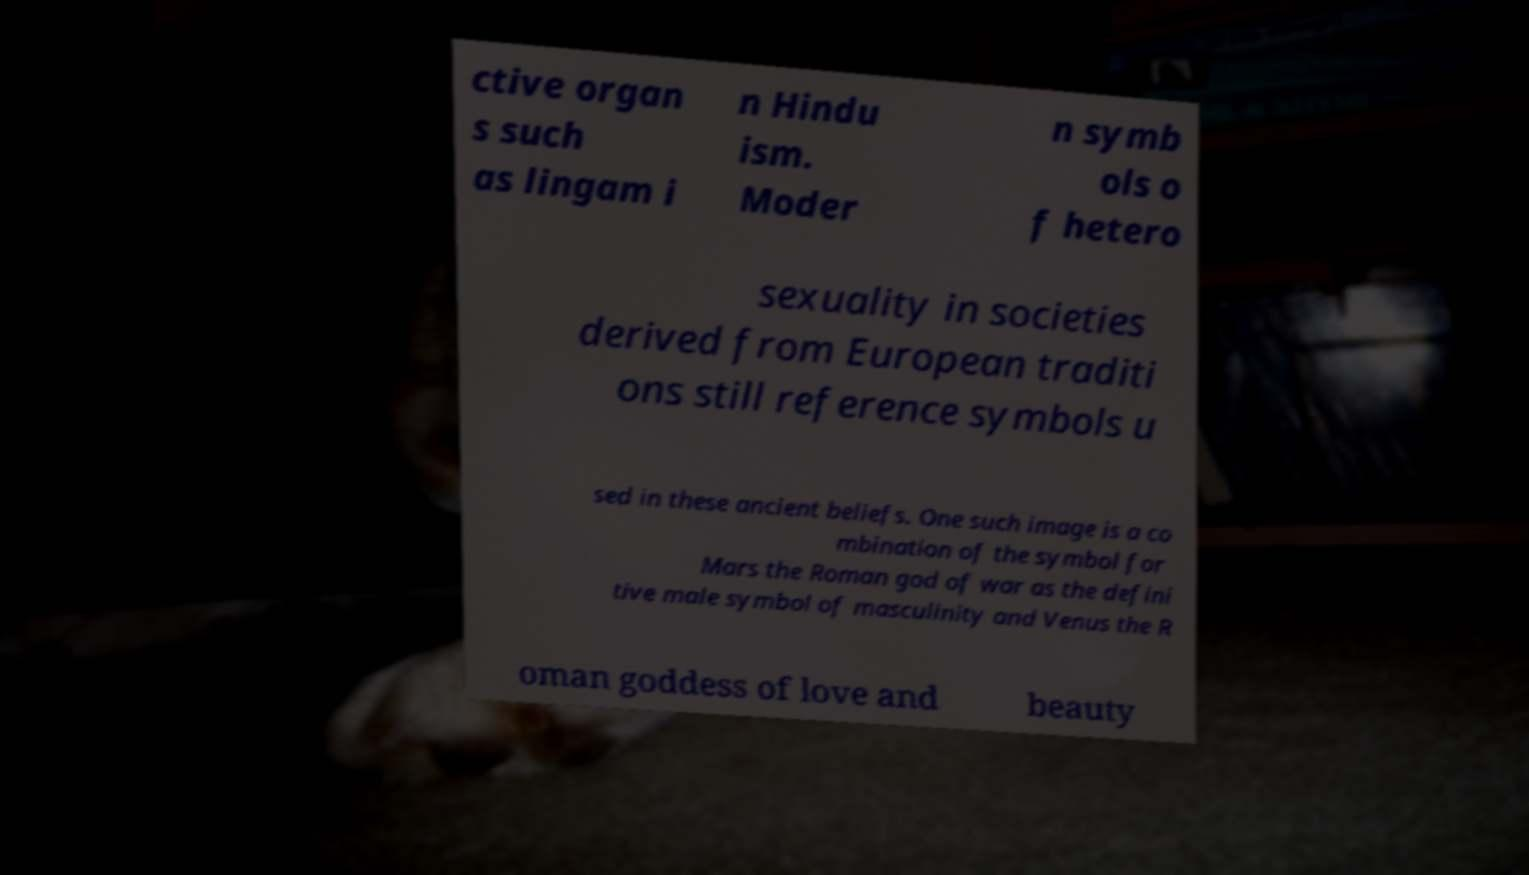Please identify and transcribe the text found in this image. ctive organ s such as lingam i n Hindu ism. Moder n symb ols o f hetero sexuality in societies derived from European traditi ons still reference symbols u sed in these ancient beliefs. One such image is a co mbination of the symbol for Mars the Roman god of war as the defini tive male symbol of masculinity and Venus the R oman goddess of love and beauty 